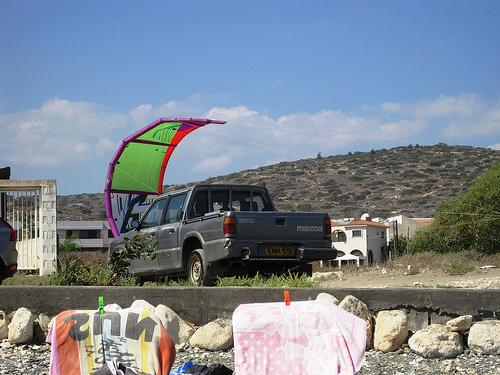Describe any unique or notable details about the landscape in the image. The landscape features a hill with dry terrain, rocky ground, and green bushes growing on the side of the road. What is the interaction between the pink towel and the chair in the image? The pink towel is draped over the chair and clipped with an orange color clip. Identify the color and type of the truck in the image. The truck is a grey Mazda truck parked on the road. In poetic language, describe the appearance of the clouds shown in the image. Soft wisps of cotton-white grace the vast azure expanse, lending an ethereal charm to the heavens above. What is the primary terrain feature present in the image? The primary terrain feature is a hill with dry terrain. Observe the greenery in the picture and provide a poetic description of its appearance. Verdant whispers of life spring forth by the roadside, a lush harmony of nature's resplendence against the backdrop of arid hills. Give a brief description of the weather and sky conditions in the image. The sky is clear and blue with white, wispy clouds. Enumerate any accessories, ornaments, or additional parts found on the truck. A yellow license plate, Mazda logo, headlights, back tire, and windows on the sides and back are found on the truck. Narrate a short sentence about the buildings and the hillock. The buildings are below a hillock with trees and green leaves nearby. What is the visual relationship between the hillock and the sky? Cloudy skies above the hillock Explain what is growing along the side of the road. Green bushes are growing on the side of the road. Which logo can be seen on the back of the truck? Mazda logo How many stories does the white building have? Two Observe the clouds in the sky and describe their appearance. The clouds are white and wispy. In your own words, describe the ground in the image. The ground is rocky with many small rocks beside concrete. Amidst the green bushes, can you find a hidden gnome? A small boat is floating on the lake behind the mountain. Briefly explain the trees around the buildings. The trees have green leaves and are located near the buildings. Identify the truck's position in relation to other objects in the image. The truck is parked on the road near a two-story white building and green bushes. Describe what the clips are doing in the image. The clips are clipping a colorfully striped dress and a pink towel to the chair. Can you spot the elephant standing next to the grey truck? The pink and purple balloons are floating in the blue sky. Describe the terrain of the hill in the background. The hill has dry terrain with rocks on the ground. Examine the environment in the given image and describe the sky. The sky is clear and blue with white clouds. What can you notice on the truck's back? A yellow license plate and Mazda logo What are the colors of the dress clipped to the chair? The dress has a colorful striped pattern. What color is the towel draped over the chair? Pink Analyze the image for any diagrams. No diagrams were found. Select the accurate description for the object found at X:325 Y:218 from the following options: A) A one-story white house B) A two-story white building C) A green bush D) A grey truck B) A two-story white building In the background, you might see a person wearing a red hat walking along the sidewalk. Notice the large fountain in front of the white house. What type of vehicle is visible in the image? A grey Mazda truck 